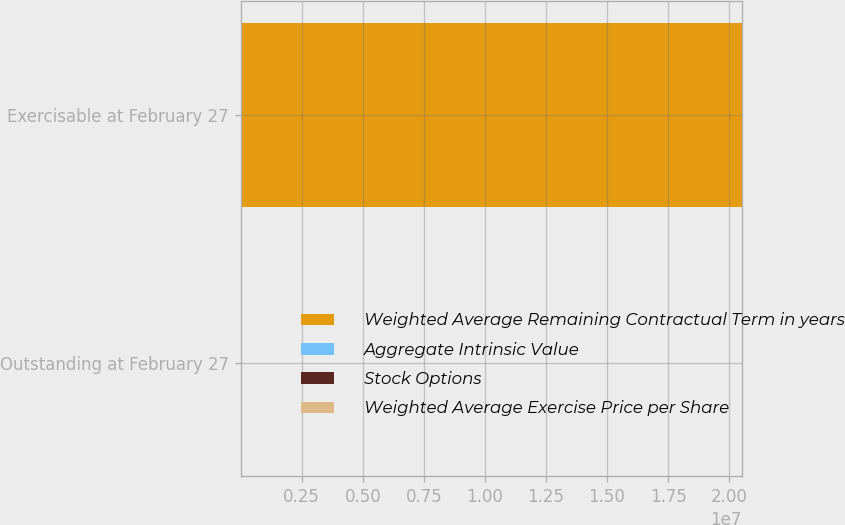Convert chart to OTSL. <chart><loc_0><loc_0><loc_500><loc_500><stacked_bar_chart><ecel><fcel>Outstanding at February 27<fcel>Exercisable at February 27<nl><fcel>Weighted Average Remaining Contractual Term in years<fcel>38.77<fcel>2.0517e+07<nl><fcel>Aggregate Intrinsic Value<fcel>38.18<fcel>38.77<nl><fcel>Stock Options<fcel>6.5<fcel>4.8<nl><fcel>Weighted Average Exercise Price per Share<fcel>110<fcel>63<nl></chart> 